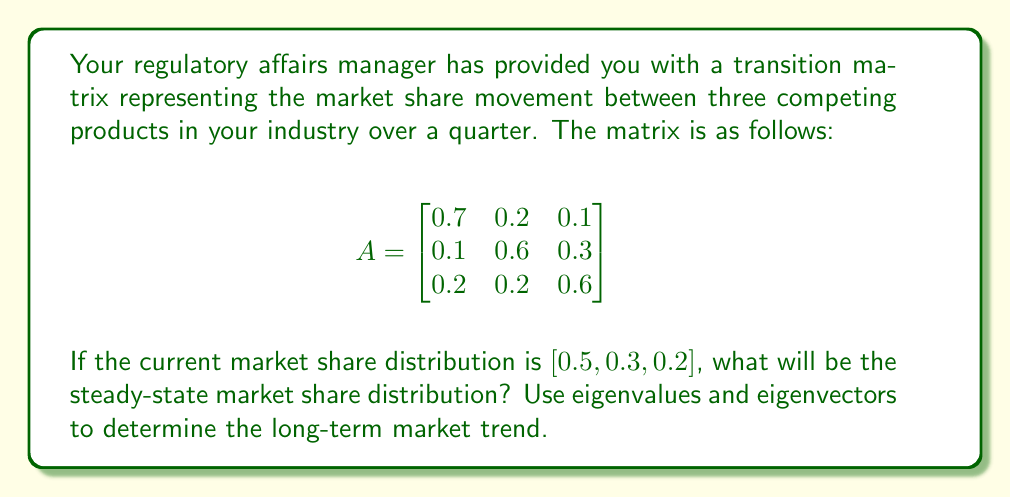Show me your answer to this math problem. To solve this problem, we need to find the steady-state distribution, which is the eigenvector corresponding to the eigenvalue 1 of the transition matrix. Here's the step-by-step process:

1. First, we need to find the eigenvalues of matrix A by solving the characteristic equation:
   $$\det(A - \lambda I) = 0$$

   $$\begin{vmatrix}
   0.7 - \lambda & 0.2 & 0.1 \\
   0.1 & 0.6 - \lambda & 0.3 \\
   0.2 & 0.2 & 0.6 - \lambda
   \end{vmatrix} = 0$$

2. Expanding this determinant:
   $$(0.7 - \lambda)((0.6 - \lambda)^2 - 0.06) - 0.2(0.1(0.6 - \lambda) - 0.3(0.2)) + 0.1(0.1(0.2) - 0.3(0.6 - \lambda)) = 0$$

3. Simplifying:
   $$-\lambda^3 + 1.9\lambda^2 - 0.94\lambda + 0.04 = 0$$

4. The roots of this equation are the eigenvalues. One of them is always 1 for a transition matrix. The others can be found numerically: $\lambda_1 = 1, \lambda_2 \approx 0.7, \lambda_3 \approx 0.2$

5. We're interested in the eigenvector corresponding to $\lambda = 1$. To find it, we solve:
   $$(A - I)v = 0$$

   $$\begin{bmatrix}
   -0.3 & 0.2 & 0.1 \\
   0.1 & -0.4 & 0.3 \\
   0.2 & 0.2 & -0.4
   \end{bmatrix}\begin{bmatrix}
   v_1 \\ v_2 \\ v_3
   \end{bmatrix} = \begin{bmatrix}
   0 \\ 0 \\ 0
   \end{bmatrix}$$

6. Solving this system of equations (and normalizing so the components sum to 1), we get:
   $$v \approx [0.4545, 0.3182, 0.2273]$$

This eigenvector represents the steady-state distribution, regardless of the initial state.
Answer: The steady-state market share distribution is approximately $[0.4545, 0.3182, 0.2273]$ or $[45.45\%, 31.82\%, 22.73\%]$ for the three products respectively. 